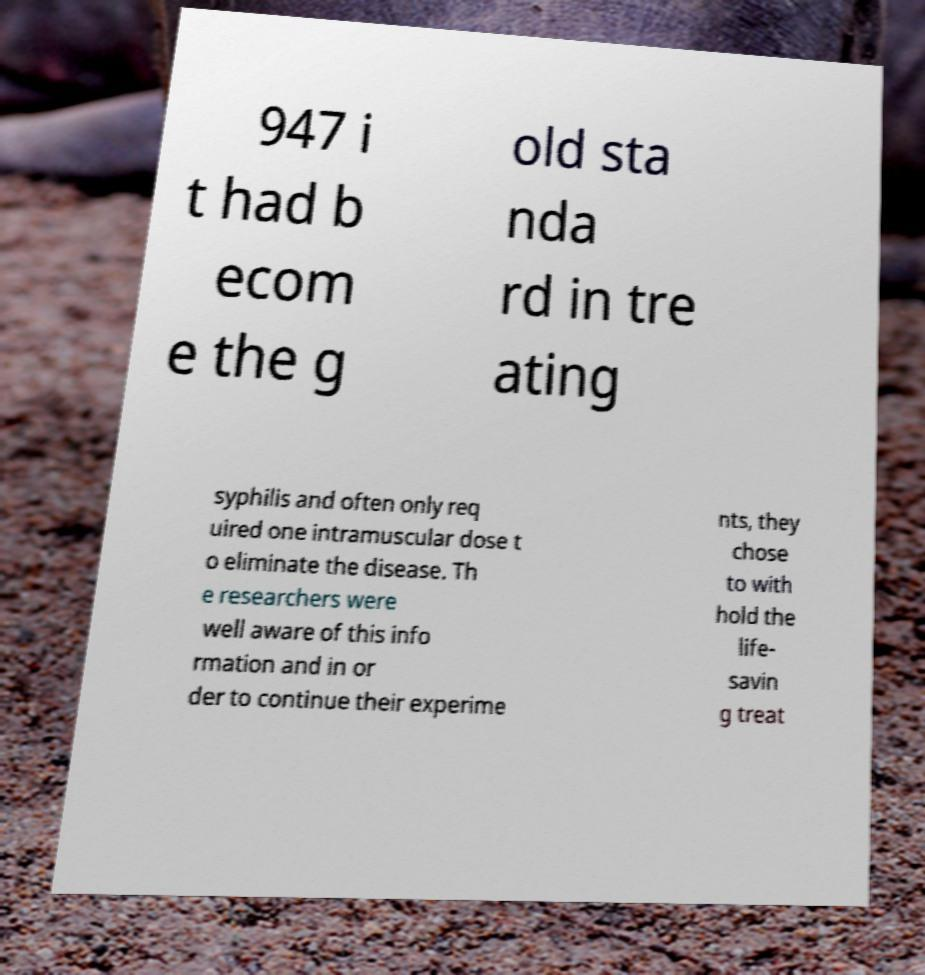Can you accurately transcribe the text from the provided image for me? 947 i t had b ecom e the g old sta nda rd in tre ating syphilis and often only req uired one intramuscular dose t o eliminate the disease. Th e researchers were well aware of this info rmation and in or der to continue their experime nts, they chose to with hold the life- savin g treat 